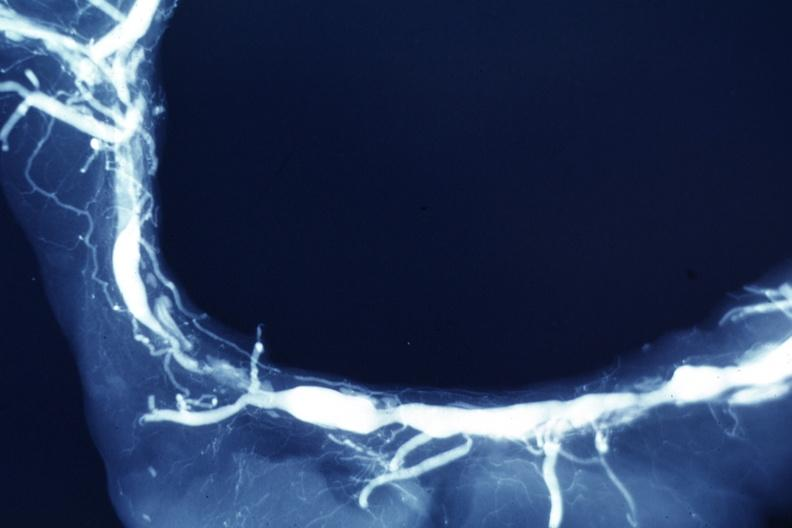what does this image show?
Answer the question using a single word or phrase. X-ray postmortclose-up view of artery with extensive lesions very good example 